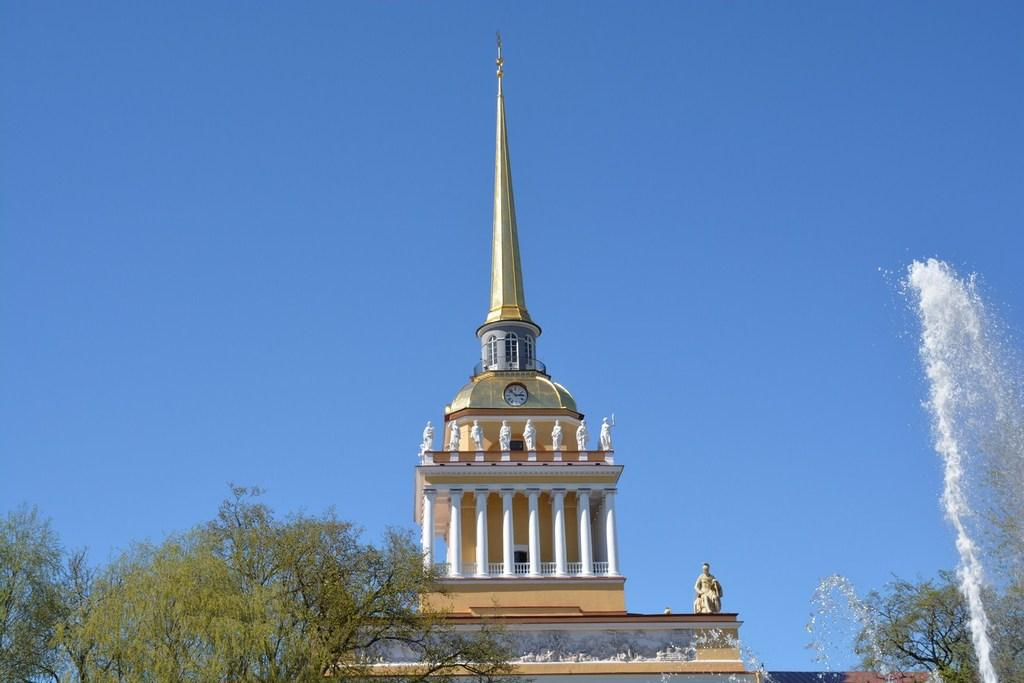What can be seen in the foreground of the image? There are trees and water visible in the foreground of the image. What is located in the background of the image? There is a building in the background of the image. What is visible at the top of the image? The sky is visible at the top of the image. What type of condition does the spade have in the image? There is no spade present in the image, so it is not possible to determine its condition. 